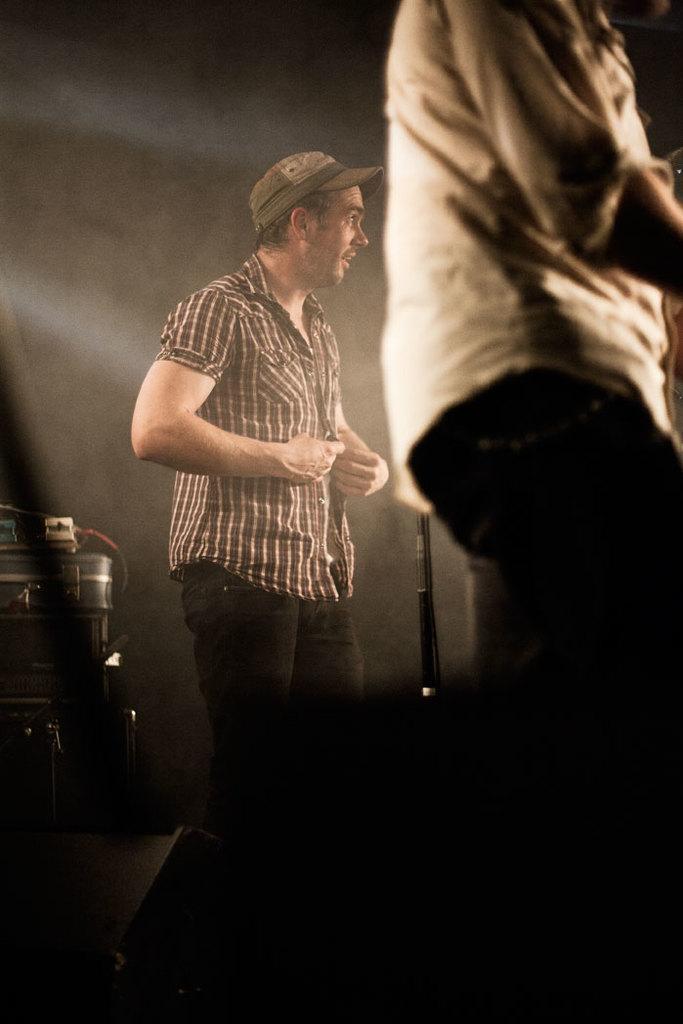Describe this image in one or two sentences. In this image I can see a person wearing shirt and pant is standing and another person wearing cap, shirt and pant is standing. I can see a microphone in front of him. In the background I can see some equipment and the dark background. 